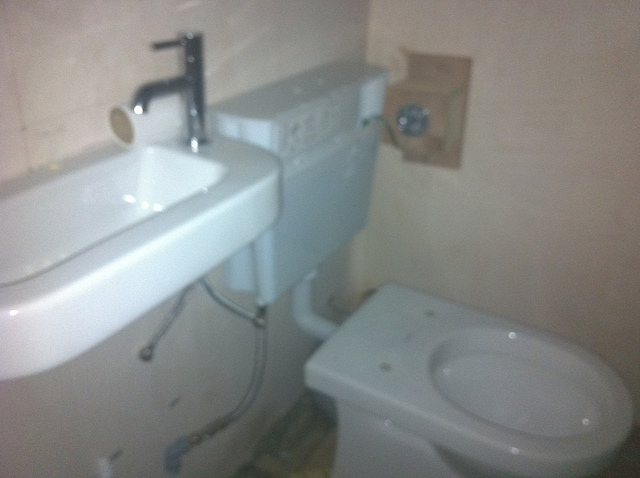Is there a mirror? There is no mirror visible in this image; typically, one might expect to find a mirror over the sink in a bathroom. 